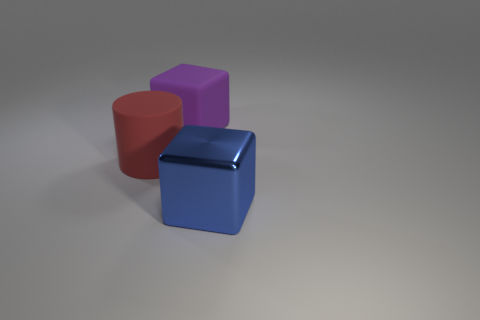Add 2 yellow spheres. How many objects exist? 5 Subtract all cubes. How many objects are left? 1 Add 2 red things. How many red things exist? 3 Subtract 0 blue balls. How many objects are left? 3 Subtract all large rubber objects. Subtract all big brown matte things. How many objects are left? 1 Add 2 large shiny things. How many large shiny things are left? 3 